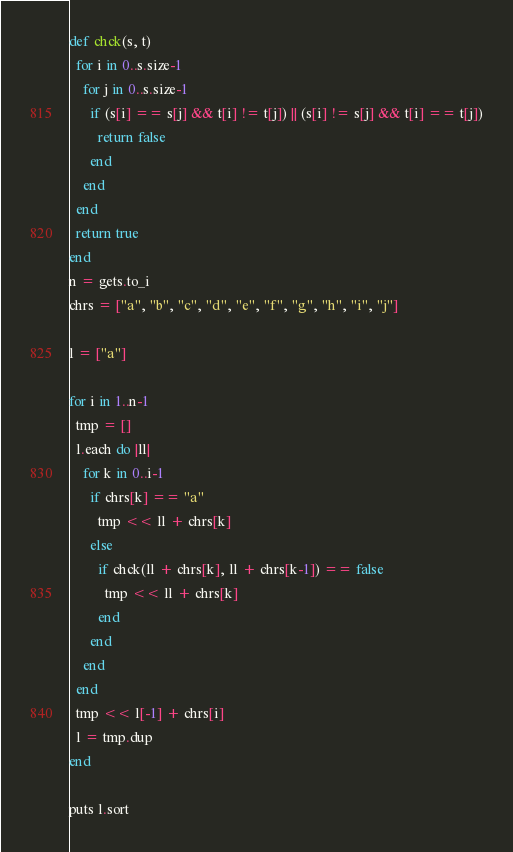<code> <loc_0><loc_0><loc_500><loc_500><_Ruby_>def chck(s, t)
  for i in 0..s.size-1
    for j in 0..s.size-1
      if (s[i] == s[j] && t[i] != t[j]) || (s[i] != s[j] && t[i] == t[j])
        return false
      end
    end
  end
  return true
end
n = gets.to_i
chrs = ["a", "b", "c", "d", "e", "f", "g", "h", "i", "j"]

l = ["a"]

for i in 1..n-1
  tmp = []
  l.each do |ll|
    for k in 0..i-1
      if chrs[k] == "a"
        tmp << ll + chrs[k]
      else
        if chck(ll + chrs[k], ll + chrs[k-1]) == false
          tmp << ll + chrs[k]
        end
      end
    end
  end
  tmp << l[-1] + chrs[i]
  l = tmp.dup
end

puts l.sort</code> 